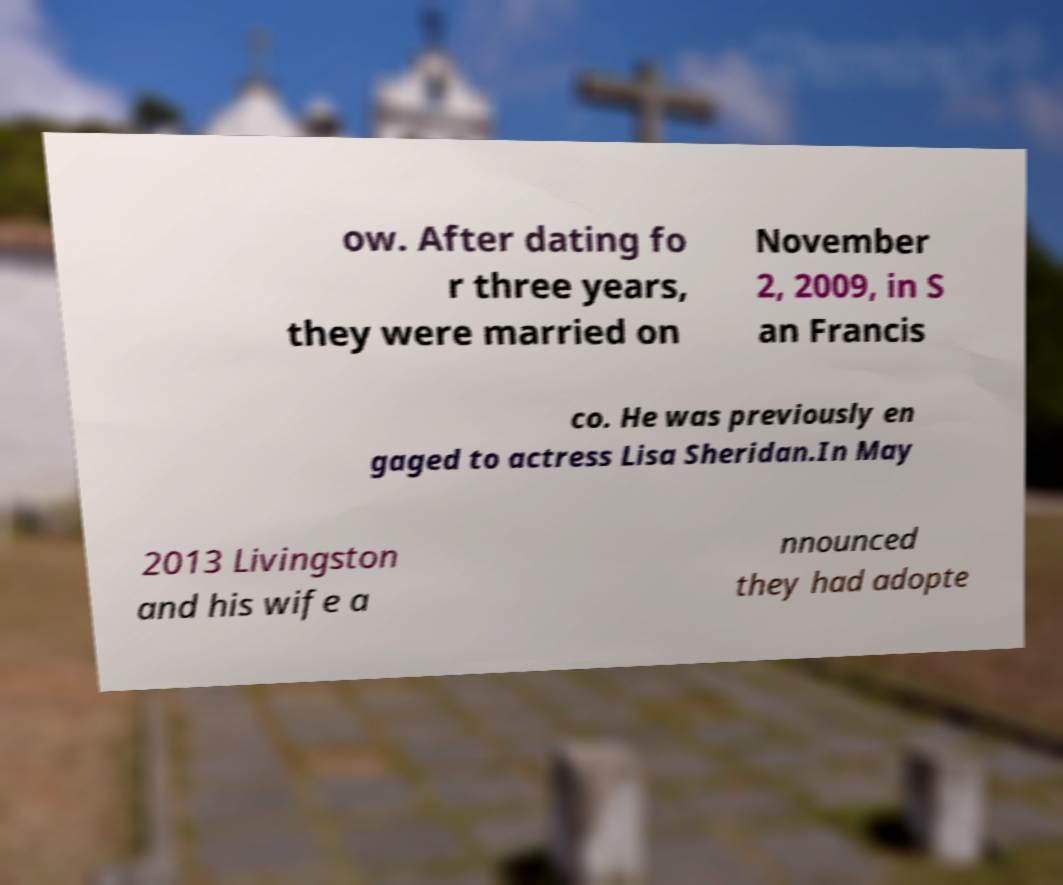What messages or text are displayed in this image? I need them in a readable, typed format. ow. After dating fo r three years, they were married on November 2, 2009, in S an Francis co. He was previously en gaged to actress Lisa Sheridan.In May 2013 Livingston and his wife a nnounced they had adopte 